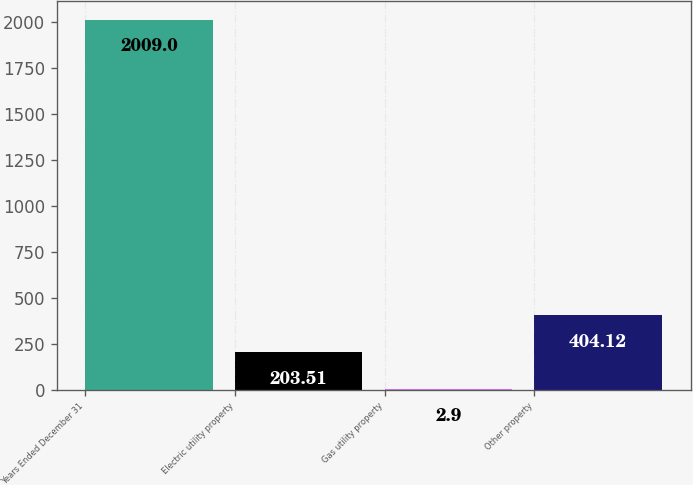Convert chart to OTSL. <chart><loc_0><loc_0><loc_500><loc_500><bar_chart><fcel>Years Ended December 31<fcel>Electric utility property<fcel>Gas utility property<fcel>Other property<nl><fcel>2009<fcel>203.51<fcel>2.9<fcel>404.12<nl></chart> 